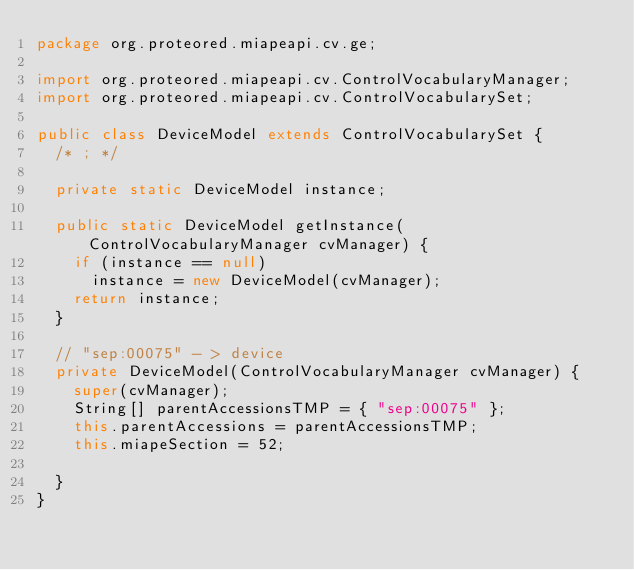<code> <loc_0><loc_0><loc_500><loc_500><_Java_>package org.proteored.miapeapi.cv.ge;

import org.proteored.miapeapi.cv.ControlVocabularyManager;
import org.proteored.miapeapi.cv.ControlVocabularySet;

public class DeviceModel extends ControlVocabularySet {
	/* ; */

	private static DeviceModel instance;

	public static DeviceModel getInstance(ControlVocabularyManager cvManager) {
		if (instance == null)
			instance = new DeviceModel(cvManager);
		return instance;
	}

	// "sep:00075" - > device
	private DeviceModel(ControlVocabularyManager cvManager) {
		super(cvManager);
		String[] parentAccessionsTMP = { "sep:00075" };
		this.parentAccessions = parentAccessionsTMP;
		this.miapeSection = 52;

	}
}
</code> 